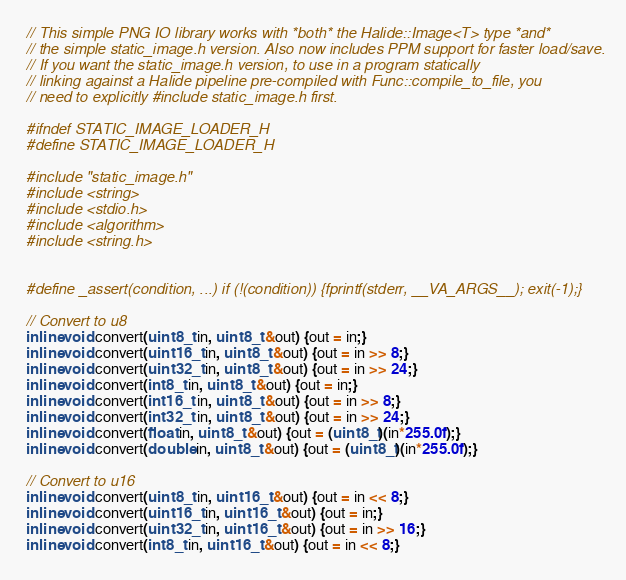Convert code to text. <code><loc_0><loc_0><loc_500><loc_500><_C_>// This simple PNG IO library works with *both* the Halide::Image<T> type *and*
// the simple static_image.h version. Also now includes PPM support for faster load/save.
// If you want the static_image.h version, to use in a program statically
// linking against a Halide pipeline pre-compiled with Func::compile_to_file, you
// need to explicitly #include static_image.h first.

#ifndef STATIC_IMAGE_LOADER_H
#define STATIC_IMAGE_LOADER_H

#include "static_image.h"
#include <string>
#include <stdio.h>
#include <algorithm>
#include <string.h>


#define _assert(condition, ...) if (!(condition)) {fprintf(stderr, __VA_ARGS__); exit(-1);}

// Convert to u8
inline void convert(uint8_t in, uint8_t &out) {out = in;}
inline void convert(uint16_t in, uint8_t &out) {out = in >> 8;}
inline void convert(uint32_t in, uint8_t &out) {out = in >> 24;}
inline void convert(int8_t in, uint8_t &out) {out = in;}
inline void convert(int16_t in, uint8_t &out) {out = in >> 8;}
inline void convert(int32_t in, uint8_t &out) {out = in >> 24;}
inline void convert(float in, uint8_t &out) {out = (uint8_t)(in*255.0f);}
inline void convert(double in, uint8_t &out) {out = (uint8_t)(in*255.0f);}

// Convert to u16
inline void convert(uint8_t in, uint16_t &out) {out = in << 8;}
inline void convert(uint16_t in, uint16_t &out) {out = in;}
inline void convert(uint32_t in, uint16_t &out) {out = in >> 16;}
inline void convert(int8_t in, uint16_t &out) {out = in << 8;}</code> 